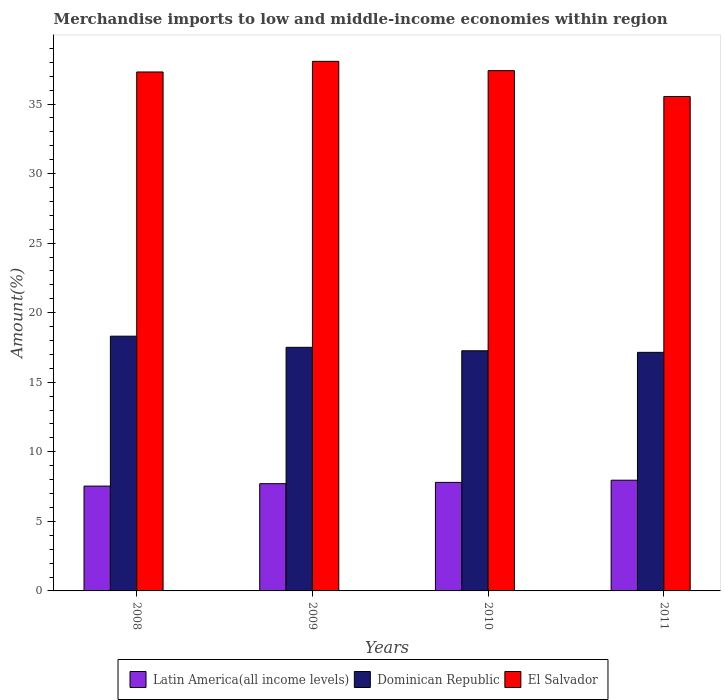Are the number of bars per tick equal to the number of legend labels?
Your answer should be very brief. Yes. Are the number of bars on each tick of the X-axis equal?
Give a very brief answer. Yes. How many bars are there on the 3rd tick from the right?
Keep it short and to the point. 3. What is the label of the 1st group of bars from the left?
Provide a succinct answer. 2008. What is the percentage of amount earned from merchandise imports in Latin America(all income levels) in 2008?
Your response must be concise. 7.53. Across all years, what is the maximum percentage of amount earned from merchandise imports in Latin America(all income levels)?
Make the answer very short. 7.96. Across all years, what is the minimum percentage of amount earned from merchandise imports in El Salvador?
Offer a very short reply. 35.54. In which year was the percentage of amount earned from merchandise imports in Dominican Republic minimum?
Provide a succinct answer. 2011. What is the total percentage of amount earned from merchandise imports in El Salvador in the graph?
Keep it short and to the point. 148.31. What is the difference between the percentage of amount earned from merchandise imports in Dominican Republic in 2008 and that in 2010?
Keep it short and to the point. 1.05. What is the difference between the percentage of amount earned from merchandise imports in El Salvador in 2008 and the percentage of amount earned from merchandise imports in Latin America(all income levels) in 2010?
Offer a terse response. 29.5. What is the average percentage of amount earned from merchandise imports in Dominican Republic per year?
Your answer should be compact. 17.56. In the year 2010, what is the difference between the percentage of amount earned from merchandise imports in Latin America(all income levels) and percentage of amount earned from merchandise imports in Dominican Republic?
Offer a very short reply. -9.46. What is the ratio of the percentage of amount earned from merchandise imports in Latin America(all income levels) in 2009 to that in 2011?
Provide a succinct answer. 0.97. Is the percentage of amount earned from merchandise imports in Dominican Republic in 2008 less than that in 2011?
Keep it short and to the point. No. Is the difference between the percentage of amount earned from merchandise imports in Latin America(all income levels) in 2008 and 2011 greater than the difference between the percentage of amount earned from merchandise imports in Dominican Republic in 2008 and 2011?
Offer a very short reply. No. What is the difference between the highest and the second highest percentage of amount earned from merchandise imports in Dominican Republic?
Your response must be concise. 0.8. What is the difference between the highest and the lowest percentage of amount earned from merchandise imports in Dominican Republic?
Your response must be concise. 1.16. What does the 2nd bar from the left in 2008 represents?
Provide a succinct answer. Dominican Republic. What does the 3rd bar from the right in 2008 represents?
Offer a very short reply. Latin America(all income levels). Is it the case that in every year, the sum of the percentage of amount earned from merchandise imports in El Salvador and percentage of amount earned from merchandise imports in Dominican Republic is greater than the percentage of amount earned from merchandise imports in Latin America(all income levels)?
Ensure brevity in your answer.  Yes. How many years are there in the graph?
Offer a very short reply. 4. Are the values on the major ticks of Y-axis written in scientific E-notation?
Your answer should be compact. No. How many legend labels are there?
Give a very brief answer. 3. What is the title of the graph?
Your answer should be compact. Merchandise imports to low and middle-income economies within region. What is the label or title of the X-axis?
Make the answer very short. Years. What is the label or title of the Y-axis?
Your answer should be compact. Amount(%). What is the Amount(%) in Latin America(all income levels) in 2008?
Ensure brevity in your answer.  7.53. What is the Amount(%) in Dominican Republic in 2008?
Keep it short and to the point. 18.31. What is the Amount(%) in El Salvador in 2008?
Give a very brief answer. 37.3. What is the Amount(%) in Latin America(all income levels) in 2009?
Ensure brevity in your answer.  7.71. What is the Amount(%) in Dominican Republic in 2009?
Your answer should be very brief. 17.51. What is the Amount(%) of El Salvador in 2009?
Provide a succinct answer. 38.07. What is the Amount(%) of Latin America(all income levels) in 2010?
Your answer should be very brief. 7.8. What is the Amount(%) in Dominican Republic in 2010?
Offer a terse response. 17.26. What is the Amount(%) of El Salvador in 2010?
Your response must be concise. 37.4. What is the Amount(%) of Latin America(all income levels) in 2011?
Your response must be concise. 7.96. What is the Amount(%) of Dominican Republic in 2011?
Offer a terse response. 17.15. What is the Amount(%) of El Salvador in 2011?
Your response must be concise. 35.54. Across all years, what is the maximum Amount(%) in Latin America(all income levels)?
Give a very brief answer. 7.96. Across all years, what is the maximum Amount(%) in Dominican Republic?
Provide a short and direct response. 18.31. Across all years, what is the maximum Amount(%) of El Salvador?
Provide a short and direct response. 38.07. Across all years, what is the minimum Amount(%) of Latin America(all income levels)?
Your answer should be compact. 7.53. Across all years, what is the minimum Amount(%) of Dominican Republic?
Make the answer very short. 17.15. Across all years, what is the minimum Amount(%) in El Salvador?
Offer a terse response. 35.54. What is the total Amount(%) of Latin America(all income levels) in the graph?
Keep it short and to the point. 31.01. What is the total Amount(%) of Dominican Republic in the graph?
Give a very brief answer. 70.24. What is the total Amount(%) in El Salvador in the graph?
Provide a short and direct response. 148.31. What is the difference between the Amount(%) in Latin America(all income levels) in 2008 and that in 2009?
Your answer should be compact. -0.17. What is the difference between the Amount(%) of Dominican Republic in 2008 and that in 2009?
Your response must be concise. 0.8. What is the difference between the Amount(%) in El Salvador in 2008 and that in 2009?
Your answer should be very brief. -0.76. What is the difference between the Amount(%) of Latin America(all income levels) in 2008 and that in 2010?
Make the answer very short. -0.27. What is the difference between the Amount(%) of Dominican Republic in 2008 and that in 2010?
Keep it short and to the point. 1.05. What is the difference between the Amount(%) of El Salvador in 2008 and that in 2010?
Offer a very short reply. -0.09. What is the difference between the Amount(%) of Latin America(all income levels) in 2008 and that in 2011?
Keep it short and to the point. -0.42. What is the difference between the Amount(%) of Dominican Republic in 2008 and that in 2011?
Your answer should be very brief. 1.16. What is the difference between the Amount(%) of El Salvador in 2008 and that in 2011?
Your response must be concise. 1.76. What is the difference between the Amount(%) of Latin America(all income levels) in 2009 and that in 2010?
Your answer should be very brief. -0.09. What is the difference between the Amount(%) of Dominican Republic in 2009 and that in 2010?
Your response must be concise. 0.25. What is the difference between the Amount(%) of El Salvador in 2009 and that in 2010?
Your response must be concise. 0.67. What is the difference between the Amount(%) of Latin America(all income levels) in 2009 and that in 2011?
Give a very brief answer. -0.25. What is the difference between the Amount(%) in Dominican Republic in 2009 and that in 2011?
Provide a short and direct response. 0.36. What is the difference between the Amount(%) of El Salvador in 2009 and that in 2011?
Provide a short and direct response. 2.53. What is the difference between the Amount(%) of Latin America(all income levels) in 2010 and that in 2011?
Your response must be concise. -0.16. What is the difference between the Amount(%) in Dominican Republic in 2010 and that in 2011?
Your answer should be compact. 0.11. What is the difference between the Amount(%) of El Salvador in 2010 and that in 2011?
Your response must be concise. 1.86. What is the difference between the Amount(%) in Latin America(all income levels) in 2008 and the Amount(%) in Dominican Republic in 2009?
Your answer should be compact. -9.98. What is the difference between the Amount(%) of Latin America(all income levels) in 2008 and the Amount(%) of El Salvador in 2009?
Keep it short and to the point. -30.53. What is the difference between the Amount(%) of Dominican Republic in 2008 and the Amount(%) of El Salvador in 2009?
Give a very brief answer. -19.76. What is the difference between the Amount(%) of Latin America(all income levels) in 2008 and the Amount(%) of Dominican Republic in 2010?
Offer a very short reply. -9.73. What is the difference between the Amount(%) of Latin America(all income levels) in 2008 and the Amount(%) of El Salvador in 2010?
Keep it short and to the point. -29.86. What is the difference between the Amount(%) in Dominican Republic in 2008 and the Amount(%) in El Salvador in 2010?
Provide a short and direct response. -19.09. What is the difference between the Amount(%) of Latin America(all income levels) in 2008 and the Amount(%) of Dominican Republic in 2011?
Make the answer very short. -9.61. What is the difference between the Amount(%) in Latin America(all income levels) in 2008 and the Amount(%) in El Salvador in 2011?
Offer a very short reply. -28.01. What is the difference between the Amount(%) of Dominican Republic in 2008 and the Amount(%) of El Salvador in 2011?
Give a very brief answer. -17.23. What is the difference between the Amount(%) in Latin America(all income levels) in 2009 and the Amount(%) in Dominican Republic in 2010?
Keep it short and to the point. -9.55. What is the difference between the Amount(%) of Latin America(all income levels) in 2009 and the Amount(%) of El Salvador in 2010?
Provide a short and direct response. -29.69. What is the difference between the Amount(%) in Dominican Republic in 2009 and the Amount(%) in El Salvador in 2010?
Provide a short and direct response. -19.89. What is the difference between the Amount(%) in Latin America(all income levels) in 2009 and the Amount(%) in Dominican Republic in 2011?
Offer a terse response. -9.44. What is the difference between the Amount(%) of Latin America(all income levels) in 2009 and the Amount(%) of El Salvador in 2011?
Provide a short and direct response. -27.83. What is the difference between the Amount(%) of Dominican Republic in 2009 and the Amount(%) of El Salvador in 2011?
Your answer should be very brief. -18.03. What is the difference between the Amount(%) of Latin America(all income levels) in 2010 and the Amount(%) of Dominican Republic in 2011?
Provide a short and direct response. -9.35. What is the difference between the Amount(%) in Latin America(all income levels) in 2010 and the Amount(%) in El Salvador in 2011?
Your response must be concise. -27.74. What is the difference between the Amount(%) of Dominican Republic in 2010 and the Amount(%) of El Salvador in 2011?
Provide a succinct answer. -18.28. What is the average Amount(%) of Latin America(all income levels) per year?
Ensure brevity in your answer.  7.75. What is the average Amount(%) in Dominican Republic per year?
Provide a succinct answer. 17.56. What is the average Amount(%) in El Salvador per year?
Offer a very short reply. 37.08. In the year 2008, what is the difference between the Amount(%) of Latin America(all income levels) and Amount(%) of Dominican Republic?
Your response must be concise. -10.78. In the year 2008, what is the difference between the Amount(%) in Latin America(all income levels) and Amount(%) in El Salvador?
Offer a very short reply. -29.77. In the year 2008, what is the difference between the Amount(%) in Dominican Republic and Amount(%) in El Salvador?
Provide a succinct answer. -18.99. In the year 2009, what is the difference between the Amount(%) of Latin America(all income levels) and Amount(%) of Dominican Republic?
Offer a terse response. -9.8. In the year 2009, what is the difference between the Amount(%) in Latin America(all income levels) and Amount(%) in El Salvador?
Your answer should be very brief. -30.36. In the year 2009, what is the difference between the Amount(%) of Dominican Republic and Amount(%) of El Salvador?
Provide a short and direct response. -20.56. In the year 2010, what is the difference between the Amount(%) in Latin America(all income levels) and Amount(%) in Dominican Republic?
Give a very brief answer. -9.46. In the year 2010, what is the difference between the Amount(%) of Latin America(all income levels) and Amount(%) of El Salvador?
Offer a terse response. -29.6. In the year 2010, what is the difference between the Amount(%) of Dominican Republic and Amount(%) of El Salvador?
Give a very brief answer. -20.14. In the year 2011, what is the difference between the Amount(%) in Latin America(all income levels) and Amount(%) in Dominican Republic?
Make the answer very short. -9.19. In the year 2011, what is the difference between the Amount(%) in Latin America(all income levels) and Amount(%) in El Salvador?
Ensure brevity in your answer.  -27.58. In the year 2011, what is the difference between the Amount(%) in Dominican Republic and Amount(%) in El Salvador?
Make the answer very short. -18.39. What is the ratio of the Amount(%) in Latin America(all income levels) in 2008 to that in 2009?
Offer a terse response. 0.98. What is the ratio of the Amount(%) of Dominican Republic in 2008 to that in 2009?
Provide a succinct answer. 1.05. What is the ratio of the Amount(%) of El Salvador in 2008 to that in 2009?
Your response must be concise. 0.98. What is the ratio of the Amount(%) in Latin America(all income levels) in 2008 to that in 2010?
Provide a succinct answer. 0.97. What is the ratio of the Amount(%) in Dominican Republic in 2008 to that in 2010?
Provide a succinct answer. 1.06. What is the ratio of the Amount(%) of El Salvador in 2008 to that in 2010?
Your answer should be very brief. 1. What is the ratio of the Amount(%) in Latin America(all income levels) in 2008 to that in 2011?
Ensure brevity in your answer.  0.95. What is the ratio of the Amount(%) in Dominican Republic in 2008 to that in 2011?
Offer a terse response. 1.07. What is the ratio of the Amount(%) of El Salvador in 2008 to that in 2011?
Ensure brevity in your answer.  1.05. What is the ratio of the Amount(%) of Latin America(all income levels) in 2009 to that in 2010?
Your answer should be very brief. 0.99. What is the ratio of the Amount(%) of Dominican Republic in 2009 to that in 2010?
Your response must be concise. 1.01. What is the ratio of the Amount(%) in El Salvador in 2009 to that in 2010?
Provide a succinct answer. 1.02. What is the ratio of the Amount(%) of Latin America(all income levels) in 2009 to that in 2011?
Give a very brief answer. 0.97. What is the ratio of the Amount(%) in Dominican Republic in 2009 to that in 2011?
Make the answer very short. 1.02. What is the ratio of the Amount(%) in El Salvador in 2009 to that in 2011?
Give a very brief answer. 1.07. What is the ratio of the Amount(%) in Latin America(all income levels) in 2010 to that in 2011?
Make the answer very short. 0.98. What is the ratio of the Amount(%) in Dominican Republic in 2010 to that in 2011?
Your response must be concise. 1.01. What is the ratio of the Amount(%) in El Salvador in 2010 to that in 2011?
Provide a succinct answer. 1.05. What is the difference between the highest and the second highest Amount(%) of Latin America(all income levels)?
Your response must be concise. 0.16. What is the difference between the highest and the second highest Amount(%) in Dominican Republic?
Offer a very short reply. 0.8. What is the difference between the highest and the second highest Amount(%) of El Salvador?
Your answer should be very brief. 0.67. What is the difference between the highest and the lowest Amount(%) in Latin America(all income levels)?
Keep it short and to the point. 0.42. What is the difference between the highest and the lowest Amount(%) in Dominican Republic?
Give a very brief answer. 1.16. What is the difference between the highest and the lowest Amount(%) in El Salvador?
Provide a succinct answer. 2.53. 